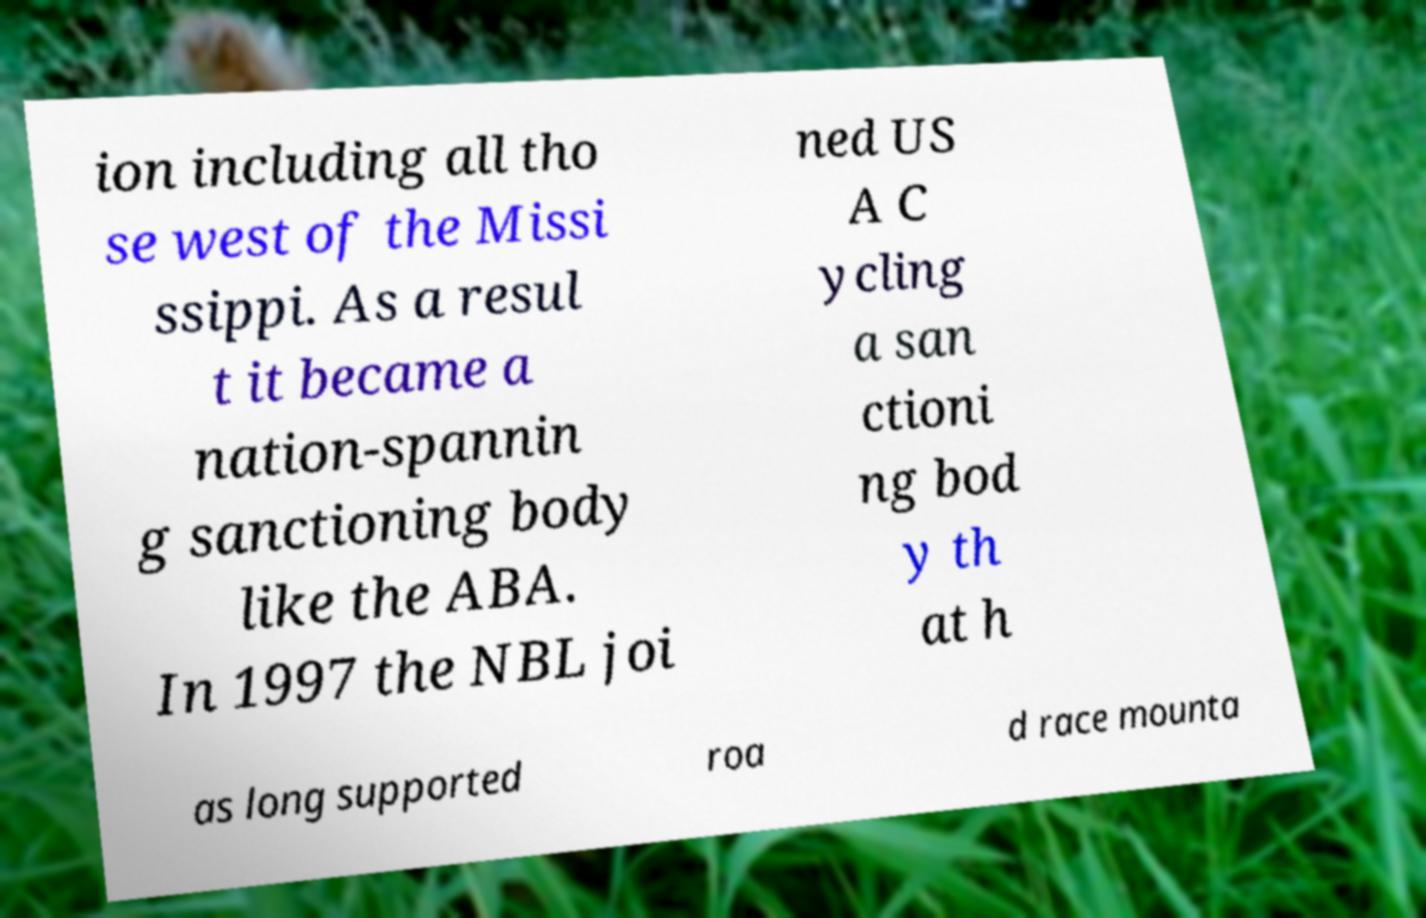What messages or text are displayed in this image? I need them in a readable, typed format. ion including all tho se west of the Missi ssippi. As a resul t it became a nation-spannin g sanctioning body like the ABA. In 1997 the NBL joi ned US A C ycling a san ctioni ng bod y th at h as long supported roa d race mounta 